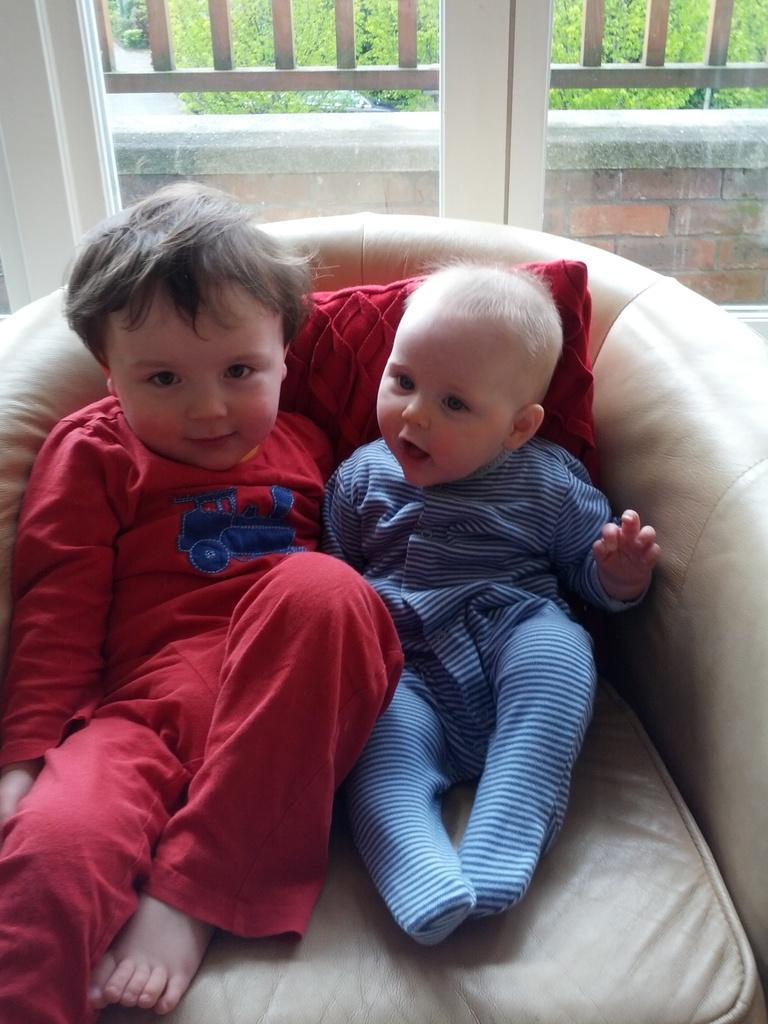How would you summarize this image in a sentence or two? In the center of the image we can see two kids sitting on the sofa and there is a cushion placed on the sofa. In the background there is a window and we can a fence and a wall through the window. 